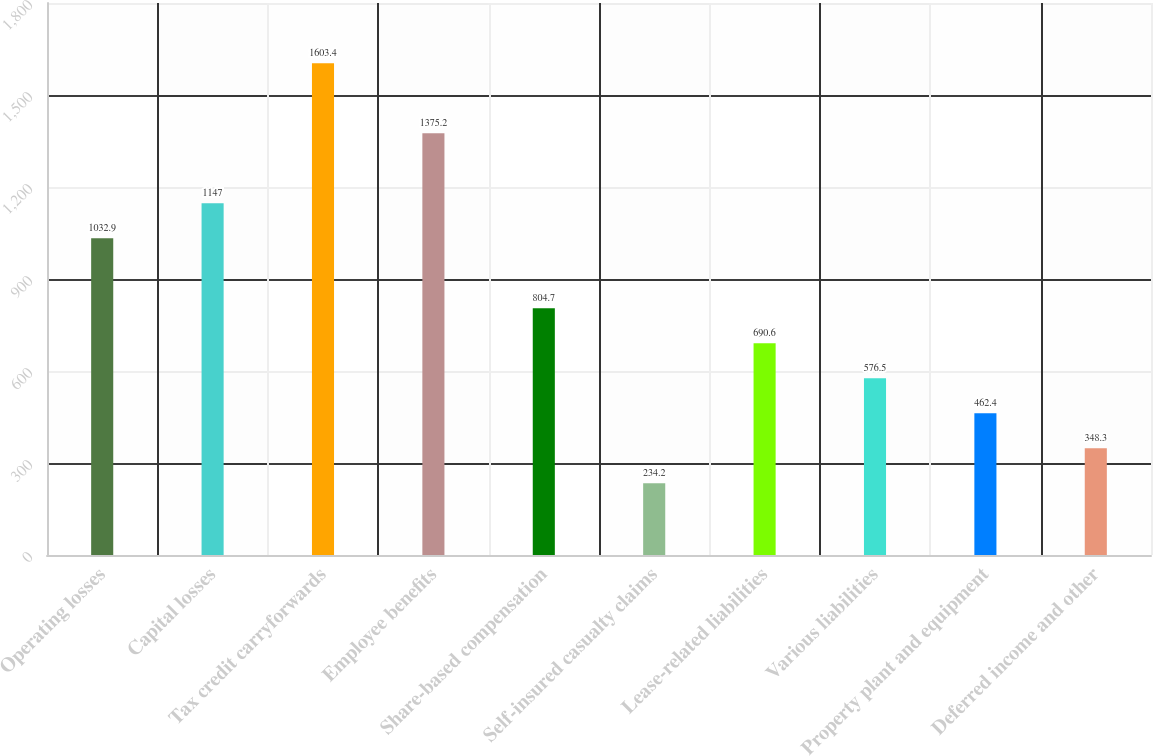Convert chart. <chart><loc_0><loc_0><loc_500><loc_500><bar_chart><fcel>Operating losses<fcel>Capital losses<fcel>Tax credit carryforwards<fcel>Employee benefits<fcel>Share-based compensation<fcel>Self-insured casualty claims<fcel>Lease-related liabilities<fcel>Various liabilities<fcel>Property plant and equipment<fcel>Deferred income and other<nl><fcel>1032.9<fcel>1147<fcel>1603.4<fcel>1375.2<fcel>804.7<fcel>234.2<fcel>690.6<fcel>576.5<fcel>462.4<fcel>348.3<nl></chart> 